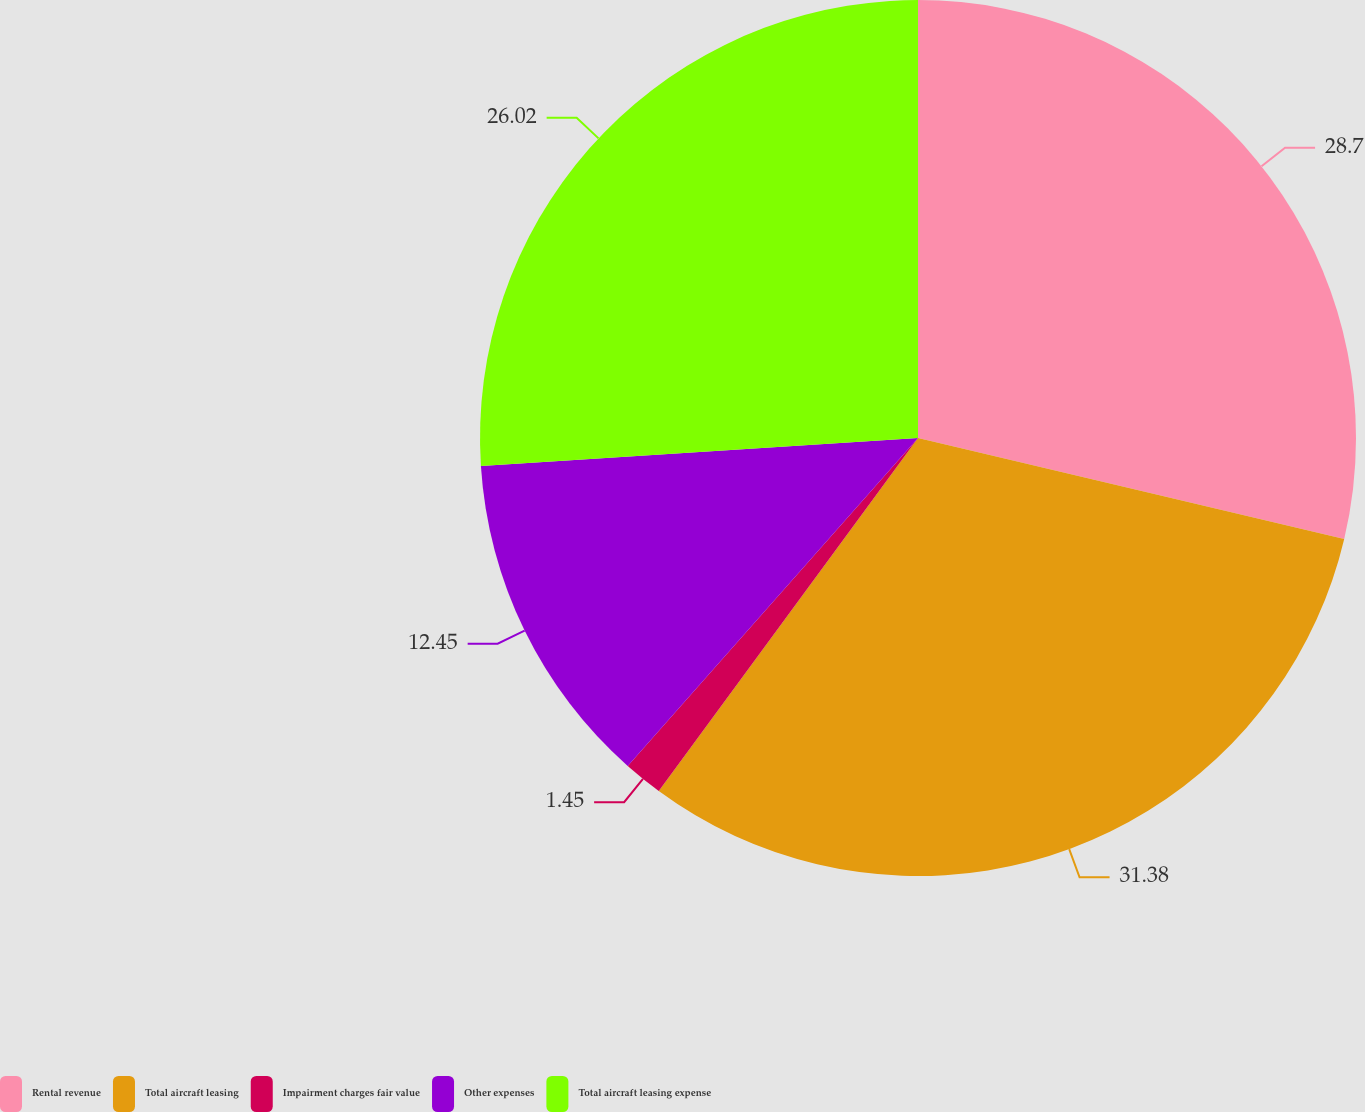Convert chart to OTSL. <chart><loc_0><loc_0><loc_500><loc_500><pie_chart><fcel>Rental revenue<fcel>Total aircraft leasing<fcel>Impairment charges fair value<fcel>Other expenses<fcel>Total aircraft leasing expense<nl><fcel>28.7%<fcel>31.38%<fcel>1.45%<fcel>12.45%<fcel>26.02%<nl></chart> 